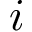Convert formula to latex. <formula><loc_0><loc_0><loc_500><loc_500>i</formula> 